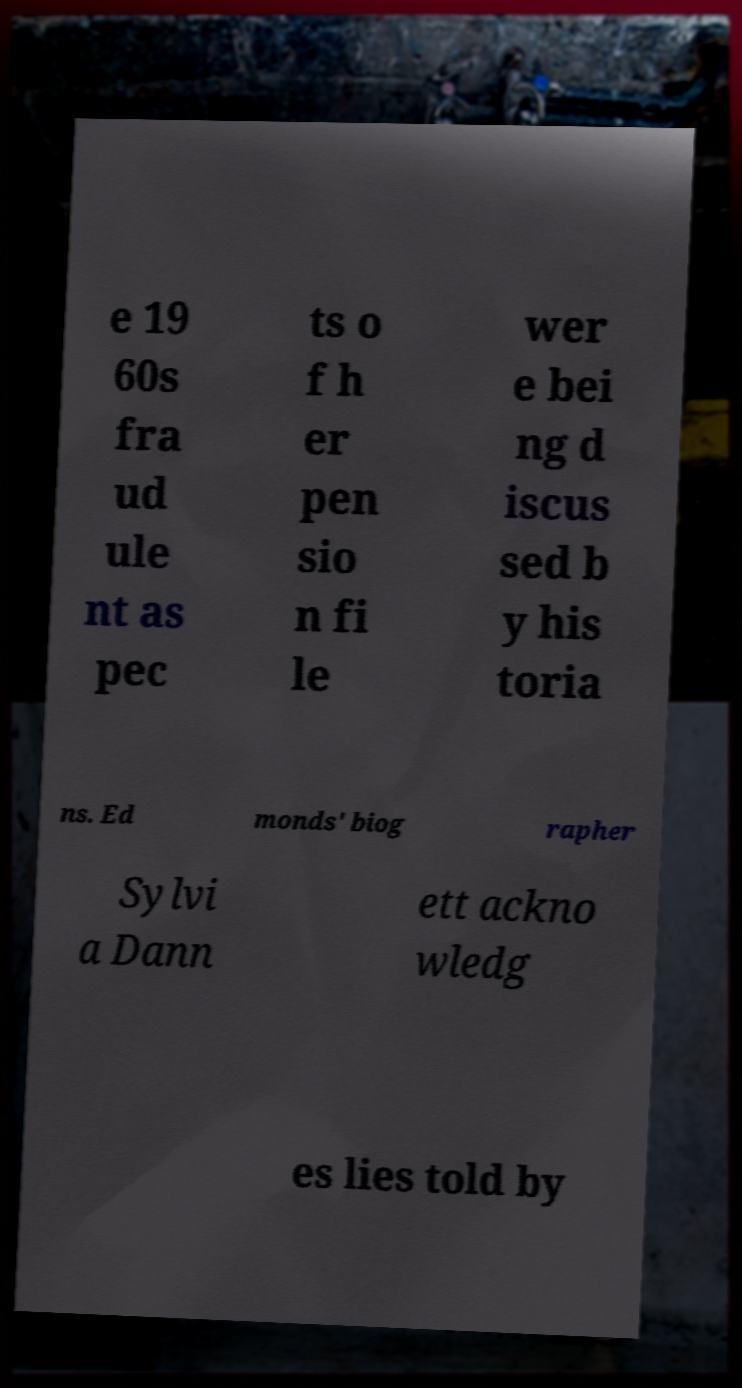For documentation purposes, I need the text within this image transcribed. Could you provide that? e 19 60s fra ud ule nt as pec ts o f h er pen sio n fi le wer e bei ng d iscus sed b y his toria ns. Ed monds' biog rapher Sylvi a Dann ett ackno wledg es lies told by 